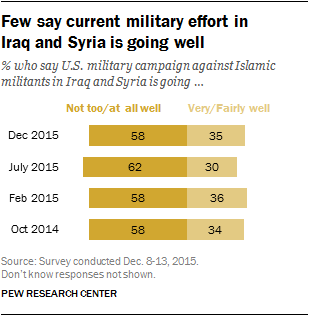Draw attention to some important aspects in this diagram. The average of the two smallest light yellow bars is 32. The dark yellow bar in the chart is represented poorly, with a lack of clarity and precision. 